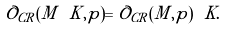Convert formula to latex. <formula><loc_0><loc_0><loc_500><loc_500>\mathcal { O } _ { C R } ( M \ K , p ) = \mathcal { O } _ { C R } ( M , p ) \ K .</formula> 